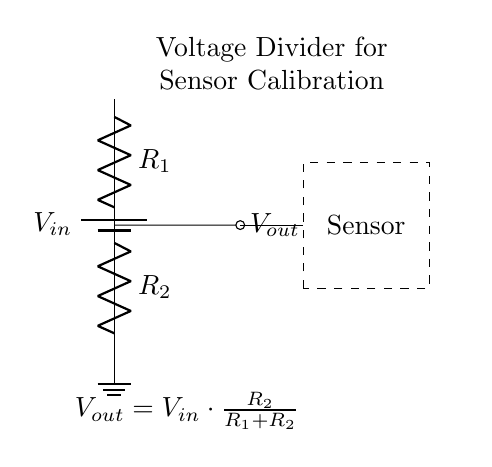What does the voltage divider output voltage depend on? The output voltage depends on the resistances of R1 and R2 as well as the input voltage Vin. Specifically, it can be calculated using the formula Vout = Vin * (R2 / (R1 + R2)).
Answer: R1, R2, and Vin What is the role of R1 in the voltage divider? R1 is one of the resistors in the voltage divider that, along with R2, determines the proportion of the input voltage that appears across the output. It affects the output voltage drop.
Answer: It divides voltage Which component is responsible for calibration in this circuit? The sensor is responsible for calibration as it utilizes the output voltage for its readings, which needs to be accurately calibrated according to the input conditions.
Answer: Sensor What is the physical configuration of the components in the circuit? The components are arranged vertically; the battery is at the top, followed by resistor R1, then resistor R2 at the bottom, with the output taken from between R1 and R2 leading to the sensor.
Answer: Vertical arrangement How is the output voltage taken in this circuit? The output voltage is taken from the junction between R1 and R2, where it is then directed to the sensor. This is the point where the voltage divider action occurs.
Answer: From R1 and R2 junction If R2 is increased while R1 remains constant, what happens to Vout? If R2 is increased, Vout increases as well because the fraction of Vin that appears across R2 becomes larger, thus raising the output voltage according to the voltage divider formula.
Answer: Vout increases 